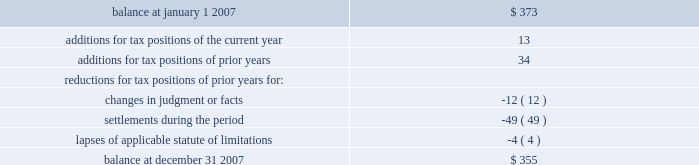United parcel service , inc .
And subsidiaries notes to consolidated financial statements 2014 ( continued ) the table summarizes the activity related to our unrecognized tax benefits ( in millions ) : .
As of december 31 , 2007 , the total amount of gross unrecognized tax benefits that , if recognized , would affect the effective tax rate was $ 134 million .
We also had gross recognized tax benefits of $ 567 million recorded as of december 31 , 2007 associated with outstanding refund claims for prior tax years .
Therefore , we had a net receivable recorded with respect to prior year income tax matters in the accompanying balance sheets .
Our continuing practice is to recognize interest and penalties associated with income tax matters as a component of income tax expense .
Related to the uncertain tax benefits noted above , we accrued penalties of $ 5 million and interest of $ 36 million during 2007 .
As of december 31 , 2007 , we have recognized a liability for penalties of $ 6 million and interest of $ 75 million .
Additionally , we have recognized a receivable for interest of $ 116 million for the recognized tax benefits associated with outstanding refund claims .
We file income tax returns in the u.s .
Federal jurisdiction , most u.s .
State and local jurisdictions , and many non-u.s .
Jurisdictions .
As of december 31 , 2007 , we had substantially resolved all u.s .
Federal income tax matters for tax years prior to 1999 .
In the third quarter of 2007 , we entered into a joint stipulation to dismiss the case with the department of justice , effectively withdrawing our refund claim related to the 1994 disposition of a subsidiary in france .
The write-off of previously recognized tax receivable balances associated with the 1994 french matter resulted in a $ 37 million increase in income tax expense for the quarter .
However , this increase was offset by the impact of favorable developments with various other u.s .
Federal , u.s .
State , and non-u.s .
Contingency matters .
In february 2008 , the irs completed its audit of the tax years 1999 through 2002 with only a limited number of issues that will be considered by the irs appeals office by 2009 .
The irs is in the final stages of completing its audit of the tax years 2003 through 2004 .
We anticipate that the irs will conclude its audit of the 2003 and 2004 tax years by 2009 .
With few exceptions , we are no longer subject to u.s .
State and local and non-u.s .
Income tax examinations by tax authorities for tax years prior to 1999 , but certain u.s .
State and local matters are subject to ongoing litigation .
A number of years may elapse before an uncertain tax position is audited and ultimately settled .
It is difficult to predict the ultimate outcome or the timing of resolution for uncertain tax positions .
It is reasonably possible that the amount of unrecognized tax benefits could significantly increase or decrease within the next twelve months .
Items that may cause changes to unrecognized tax benefits include the timing of interest deductions , the deductibility of acquisition costs , the consideration of filing requirements in various states , the allocation of income and expense between tax jurisdictions and the effects of terminating an election to have a foreign subsidiary join in filing a consolidated return .
These changes could result from the settlement of ongoing litigation , the completion of ongoing examinations , the expiration of the statute of limitations , or other unforeseen circumstances .
At this time , an estimate of the range of the reasonably possible change cannot be .
What is the net change in the balance of unrecognized tax benefits during 2007? 
Computations: (355 - 373)
Answer: -18.0. United parcel service , inc .
And subsidiaries notes to consolidated financial statements 2014 ( continued ) the table summarizes the activity related to our unrecognized tax benefits ( in millions ) : .
As of december 31 , 2007 , the total amount of gross unrecognized tax benefits that , if recognized , would affect the effective tax rate was $ 134 million .
We also had gross recognized tax benefits of $ 567 million recorded as of december 31 , 2007 associated with outstanding refund claims for prior tax years .
Therefore , we had a net receivable recorded with respect to prior year income tax matters in the accompanying balance sheets .
Our continuing practice is to recognize interest and penalties associated with income tax matters as a component of income tax expense .
Related to the uncertain tax benefits noted above , we accrued penalties of $ 5 million and interest of $ 36 million during 2007 .
As of december 31 , 2007 , we have recognized a liability for penalties of $ 6 million and interest of $ 75 million .
Additionally , we have recognized a receivable for interest of $ 116 million for the recognized tax benefits associated with outstanding refund claims .
We file income tax returns in the u.s .
Federal jurisdiction , most u.s .
State and local jurisdictions , and many non-u.s .
Jurisdictions .
As of december 31 , 2007 , we had substantially resolved all u.s .
Federal income tax matters for tax years prior to 1999 .
In the third quarter of 2007 , we entered into a joint stipulation to dismiss the case with the department of justice , effectively withdrawing our refund claim related to the 1994 disposition of a subsidiary in france .
The write-off of previously recognized tax receivable balances associated with the 1994 french matter resulted in a $ 37 million increase in income tax expense for the quarter .
However , this increase was offset by the impact of favorable developments with various other u.s .
Federal , u.s .
State , and non-u.s .
Contingency matters .
In february 2008 , the irs completed its audit of the tax years 1999 through 2002 with only a limited number of issues that will be considered by the irs appeals office by 2009 .
The irs is in the final stages of completing its audit of the tax years 2003 through 2004 .
We anticipate that the irs will conclude its audit of the 2003 and 2004 tax years by 2009 .
With few exceptions , we are no longer subject to u.s .
State and local and non-u.s .
Income tax examinations by tax authorities for tax years prior to 1999 , but certain u.s .
State and local matters are subject to ongoing litigation .
A number of years may elapse before an uncertain tax position is audited and ultimately settled .
It is difficult to predict the ultimate outcome or the timing of resolution for uncertain tax positions .
It is reasonably possible that the amount of unrecognized tax benefits could significantly increase or decrease within the next twelve months .
Items that may cause changes to unrecognized tax benefits include the timing of interest deductions , the deductibility of acquisition costs , the consideration of filing requirements in various states , the allocation of income and expense between tax jurisdictions and the effects of terminating an election to have a foreign subsidiary join in filing a consolidated return .
These changes could result from the settlement of ongoing litigation , the completion of ongoing examinations , the expiration of the statute of limitations , or other unforeseen circumstances .
At this time , an estimate of the range of the reasonably possible change cannot be .
What was the net change in the unrecognized tax benefit from january 1 , 2007 to december 31 , 2007 , in millions? 
Computations: (355 - 373)
Answer: -18.0. 